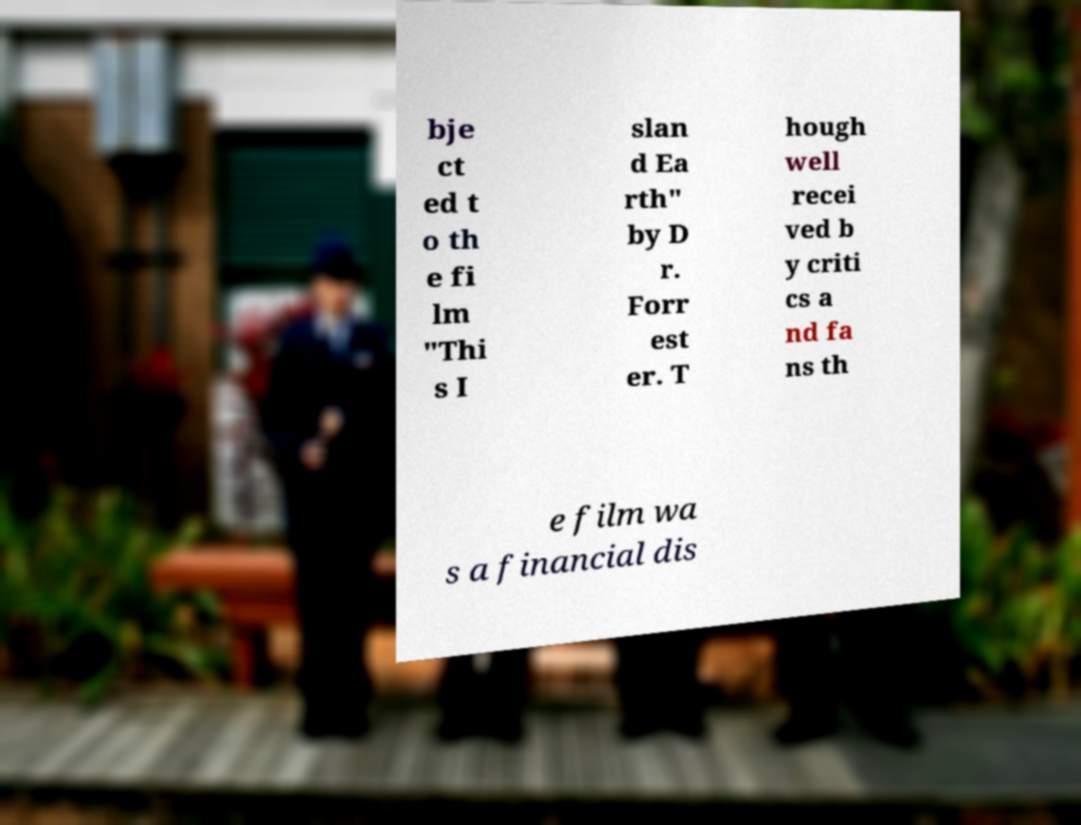Please identify and transcribe the text found in this image. bje ct ed t o th e fi lm "Thi s I slan d Ea rth" by D r. Forr est er. T hough well recei ved b y criti cs a nd fa ns th e film wa s a financial dis 